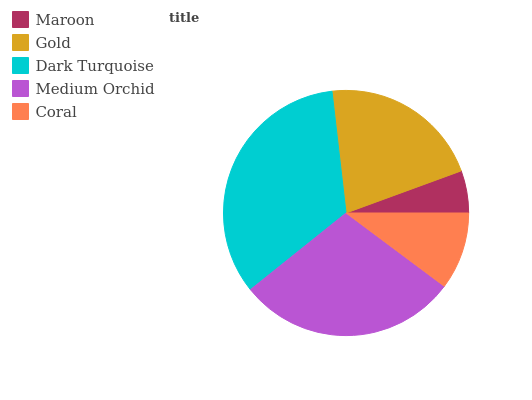Is Maroon the minimum?
Answer yes or no. Yes. Is Dark Turquoise the maximum?
Answer yes or no. Yes. Is Gold the minimum?
Answer yes or no. No. Is Gold the maximum?
Answer yes or no. No. Is Gold greater than Maroon?
Answer yes or no. Yes. Is Maroon less than Gold?
Answer yes or no. Yes. Is Maroon greater than Gold?
Answer yes or no. No. Is Gold less than Maroon?
Answer yes or no. No. Is Gold the high median?
Answer yes or no. Yes. Is Gold the low median?
Answer yes or no. Yes. Is Maroon the high median?
Answer yes or no. No. Is Dark Turquoise the low median?
Answer yes or no. No. 